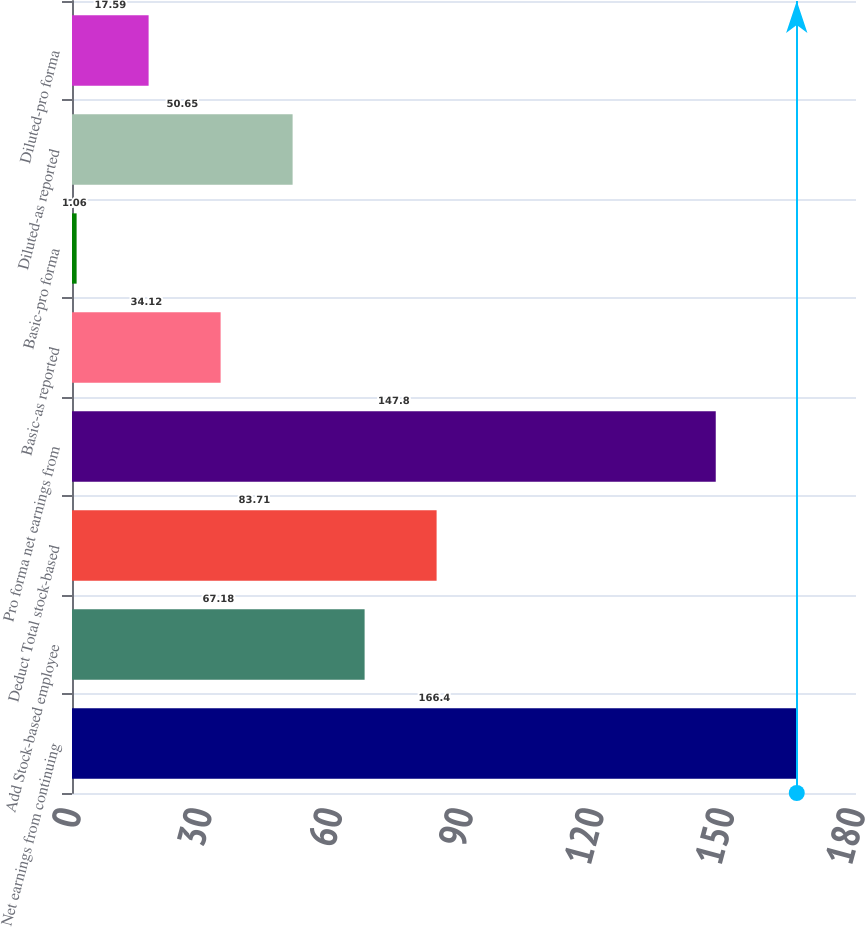<chart> <loc_0><loc_0><loc_500><loc_500><bar_chart><fcel>Net earnings from continuing<fcel>Add Stock-based employee<fcel>Deduct Total stock-based<fcel>Pro forma net earnings from<fcel>Basic-as reported<fcel>Basic-pro forma<fcel>Diluted-as reported<fcel>Diluted-pro forma<nl><fcel>166.4<fcel>67.18<fcel>83.71<fcel>147.8<fcel>34.12<fcel>1.06<fcel>50.65<fcel>17.59<nl></chart> 